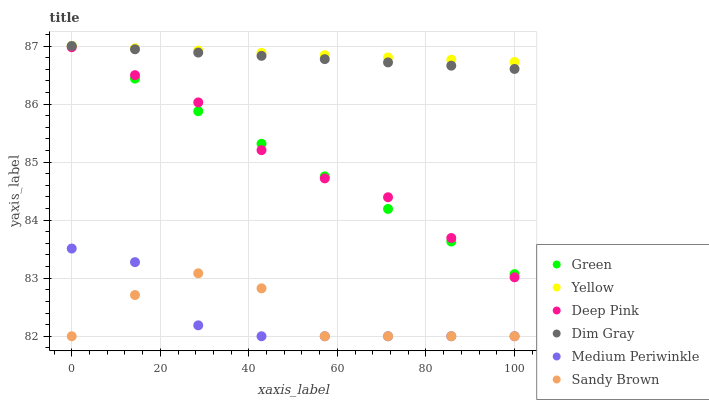Does Medium Periwinkle have the minimum area under the curve?
Answer yes or no. Yes. Does Yellow have the maximum area under the curve?
Answer yes or no. Yes. Does Yellow have the minimum area under the curve?
Answer yes or no. No. Does Medium Periwinkle have the maximum area under the curve?
Answer yes or no. No. Is Yellow the smoothest?
Answer yes or no. Yes. Is Sandy Brown the roughest?
Answer yes or no. Yes. Is Medium Periwinkle the smoothest?
Answer yes or no. No. Is Medium Periwinkle the roughest?
Answer yes or no. No. Does Medium Periwinkle have the lowest value?
Answer yes or no. Yes. Does Yellow have the lowest value?
Answer yes or no. No. Does Green have the highest value?
Answer yes or no. Yes. Does Medium Periwinkle have the highest value?
Answer yes or no. No. Is Medium Periwinkle less than Yellow?
Answer yes or no. Yes. Is Green greater than Medium Periwinkle?
Answer yes or no. Yes. Does Sandy Brown intersect Medium Periwinkle?
Answer yes or no. Yes. Is Sandy Brown less than Medium Periwinkle?
Answer yes or no. No. Is Sandy Brown greater than Medium Periwinkle?
Answer yes or no. No. Does Medium Periwinkle intersect Yellow?
Answer yes or no. No. 